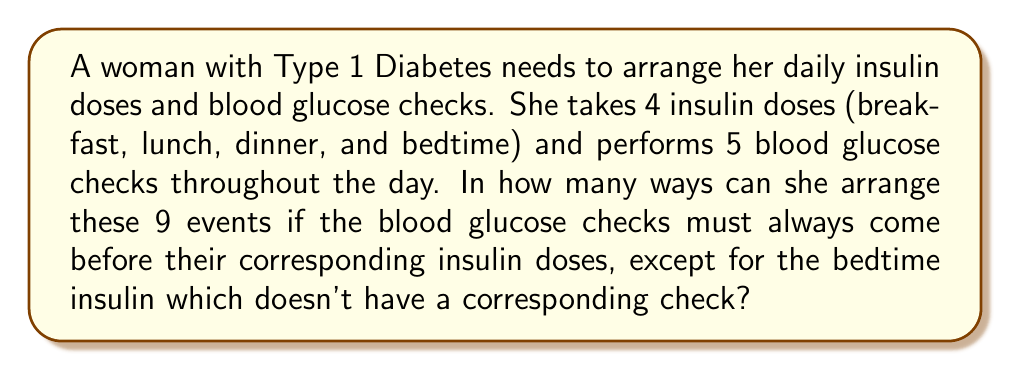What is the answer to this math problem? Let's approach this step-by-step:

1) First, we need to understand the constraints:
   - There are 9 total events: 4 insulin doses and 5 blood glucose checks
   - 4 of the blood glucose checks must precede their corresponding insulin doses
   - The bedtime insulin dose doesn't have a corresponding check

2) Let's pair the 4 blood glucose checks with their corresponding insulin doses:
   $$(BG_1, I_1), (BG_2, I_2), (BG_3, I_3), (BG_4, I_4)$$
   Where $BG$ represents a blood glucose check and $I$ represents an insulin dose.

3) Now we have 5 elements to arrange:
   - 4 pairs $(BG, I)$
   - 1 extra blood glucose check
   - 1 bedtime insulin dose

4) The number of ways to arrange these 6 elements is $6!$

5) However, within each $(BG, I)$ pair, the blood glucose check must come before the insulin dose. This halves the number of arrangements for each pair.

6) Since there are 4 such pairs, we need to divide by $2^4 = 16$

7) Therefore, the total number of valid arrangements is:

   $$\frac{6!}{2^4} = \frac{720}{16} = 45$$
Answer: 45 